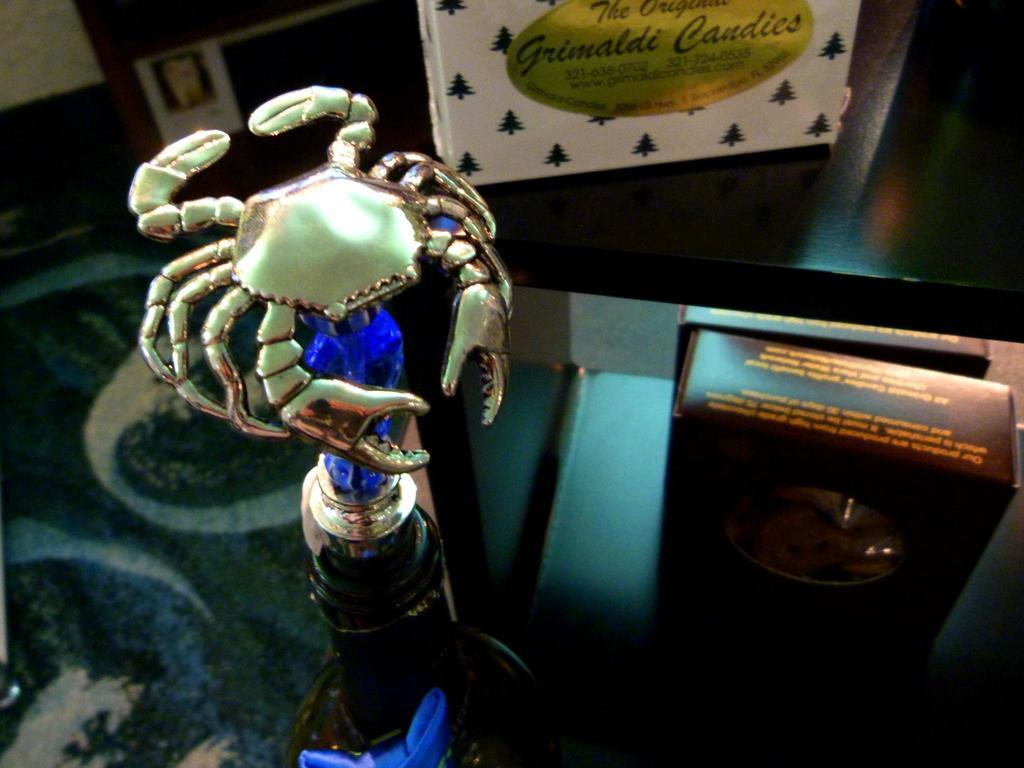What is the main subject of the image? The main subject of the image is a crab sculpture. Where is the crab sculpture located? The crab sculpture is on an object. What else can be seen in the image besides the crab sculpture? There are boxes on a platform and objects visible in the background on the left side of the image. How much profit did the desk generate in the image? There is no desk present in the image, so it is not possible to determine any profit generated. 